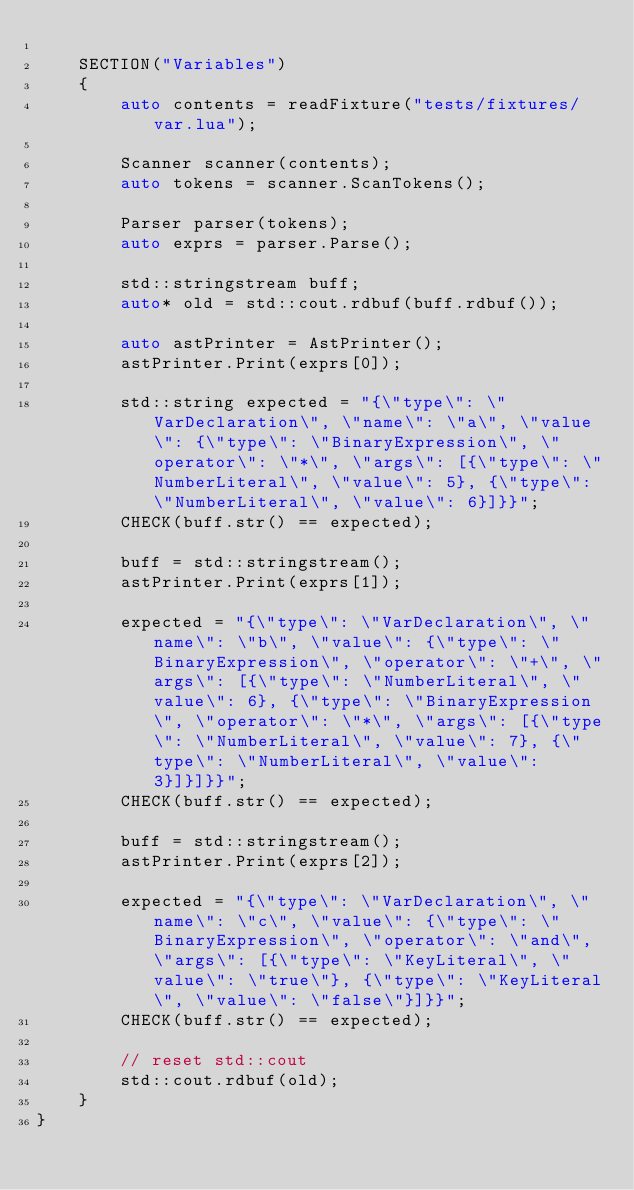<code> <loc_0><loc_0><loc_500><loc_500><_C++_>
    SECTION("Variables")
    {
        auto contents = readFixture("tests/fixtures/var.lua");

        Scanner scanner(contents);
        auto tokens = scanner.ScanTokens();

        Parser parser(tokens);
        auto exprs = parser.Parse();

        std::stringstream buff;
        auto* old = std::cout.rdbuf(buff.rdbuf());

        auto astPrinter = AstPrinter();
        astPrinter.Print(exprs[0]);

        std::string expected = "{\"type\": \"VarDeclaration\", \"name\": \"a\", \"value\": {\"type\": \"BinaryExpression\", \"operator\": \"*\", \"args\": [{\"type\": \"NumberLiteral\", \"value\": 5}, {\"type\": \"NumberLiteral\", \"value\": 6}]}}";
        CHECK(buff.str() == expected);

        buff = std::stringstream();
        astPrinter.Print(exprs[1]);

        expected = "{\"type\": \"VarDeclaration\", \"name\": \"b\", \"value\": {\"type\": \"BinaryExpression\", \"operator\": \"+\", \"args\": [{\"type\": \"NumberLiteral\", \"value\": 6}, {\"type\": \"BinaryExpression\", \"operator\": \"*\", \"args\": [{\"type\": \"NumberLiteral\", \"value\": 7}, {\"type\": \"NumberLiteral\", \"value\": 3}]}]}}";
        CHECK(buff.str() == expected);

        buff = std::stringstream();
        astPrinter.Print(exprs[2]);

        expected = "{\"type\": \"VarDeclaration\", \"name\": \"c\", \"value\": {\"type\": \"BinaryExpression\", \"operator\": \"and\", \"args\": [{\"type\": \"KeyLiteral\", \"value\": \"true\"}, {\"type\": \"KeyLiteral\", \"value\": \"false\"}]}}";
        CHECK(buff.str() == expected);

        // reset std::cout
        std::cout.rdbuf(old);
    }
}
</code> 